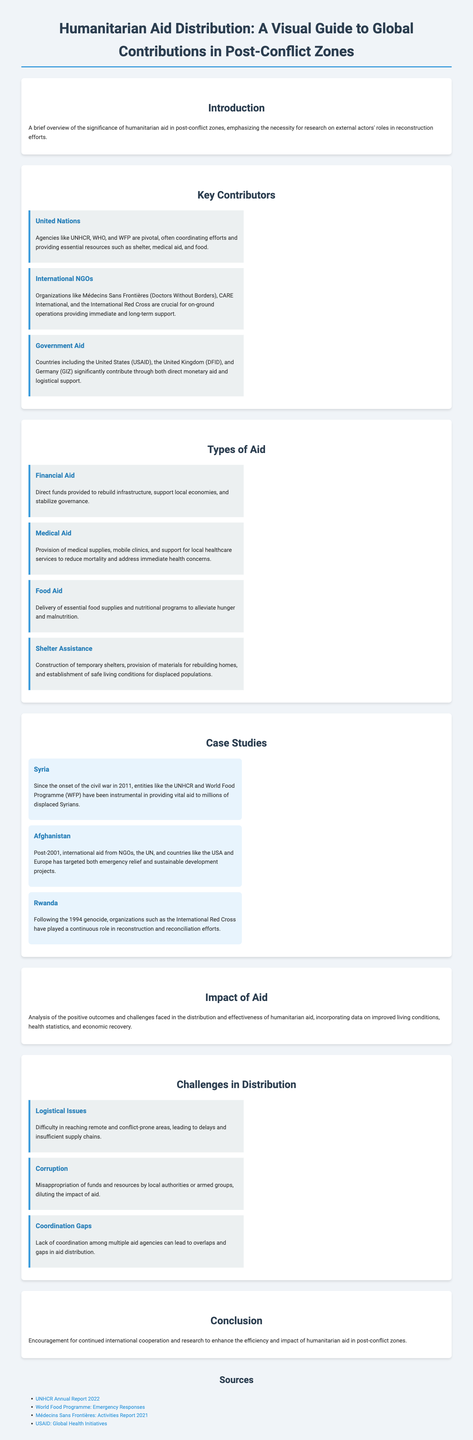What is the title of the document? The title of the document is listed at the top, summarizing the topic it covers.
Answer: Humanitarian Aid Distribution: A Visual Guide to Global Contributions in Post-Conflict Zones Which organization is primarily responsible for coordinating humanitarian efforts? The organization mentioned as pivotal in coordinating efforts and providing essential resources is highlighted in the 'Key Contributors' section.
Answer: United Nations What type of aid includes medical supplies and mobile clinics? This type of aid is specified in the 'Types of Aid' section, where it details support for local healthcare services.
Answer: Medical Aid Name one country contributing significant aid through governmental channels. The document lists specific countries providing substantial aid, which can be found under the 'Key Contributors' section.
Answer: United States Which case study focuses on the aftermath of a civil war in 2011? This information can be found in the 'Case Studies' section, identifying the specific regional impact of the conflict mentioned.
Answer: Syria What are two major issues faced in the distribution of humanitarian aid? The 'Challenges in Distribution' section outlines specific challenges that hinder effective aid distribution.
Answer: Logistical Issues, Corruption What type of aid helps alleviate hunger and malnutrition? This type of aid is categorized in the 'Types of Aid' section, specifically addressing the nutritional needs of affected populations.
Answer: Food Aid What organization is known for on-ground operations in humanitarian aid? The document mentions a specific type of organization that plays a crucial role in implementation and support during crises.
Answer: International NGOs What is the purpose of the conclusion in the document? The conclusion emphasizes a call for action to enhance the efficiency and impact of humanitarian efforts.
Answer: Encourage cooperation and research 